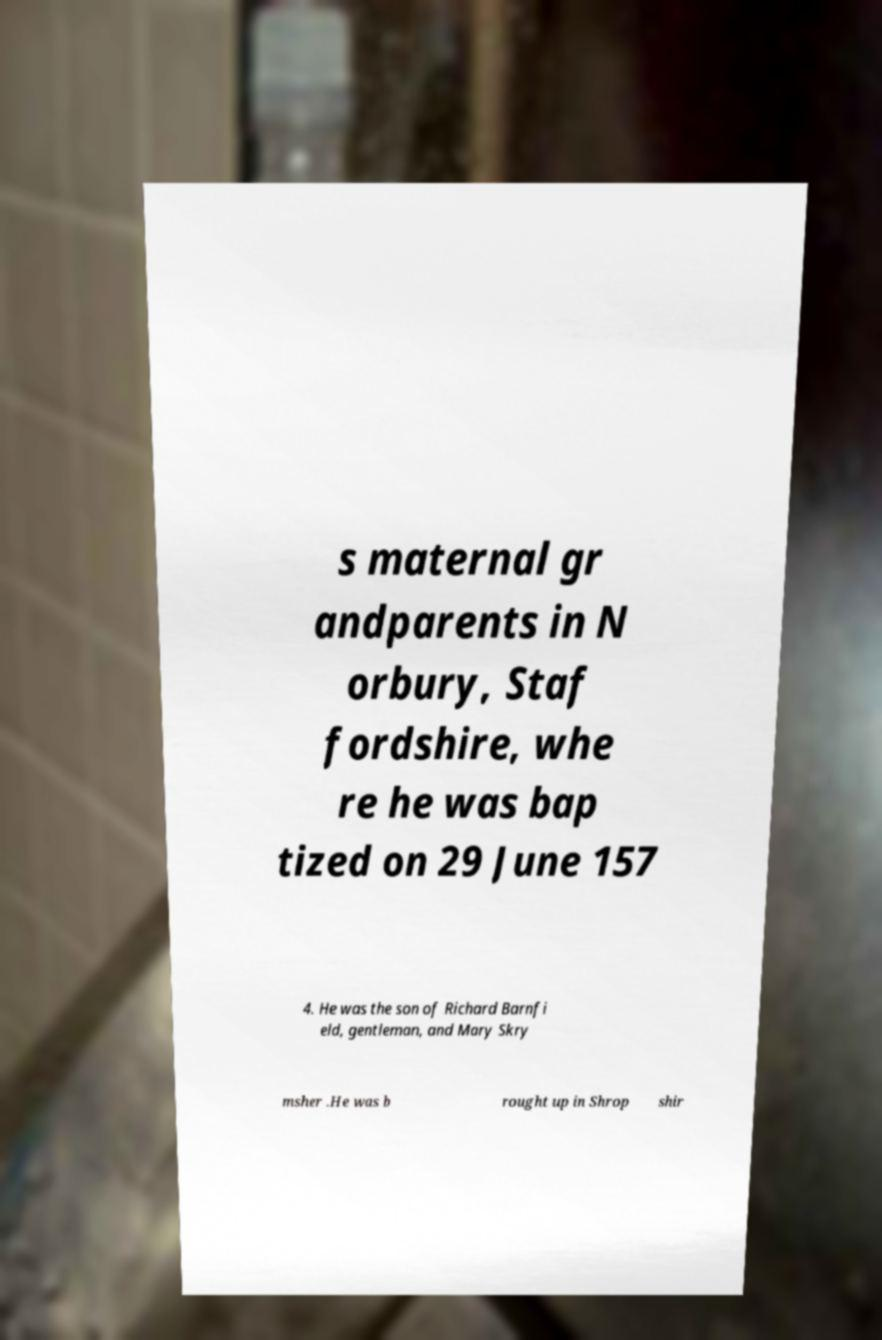Could you assist in decoding the text presented in this image and type it out clearly? s maternal gr andparents in N orbury, Staf fordshire, whe re he was bap tized on 29 June 157 4. He was the son of Richard Barnfi eld, gentleman, and Mary Skry msher .He was b rought up in Shrop shir 